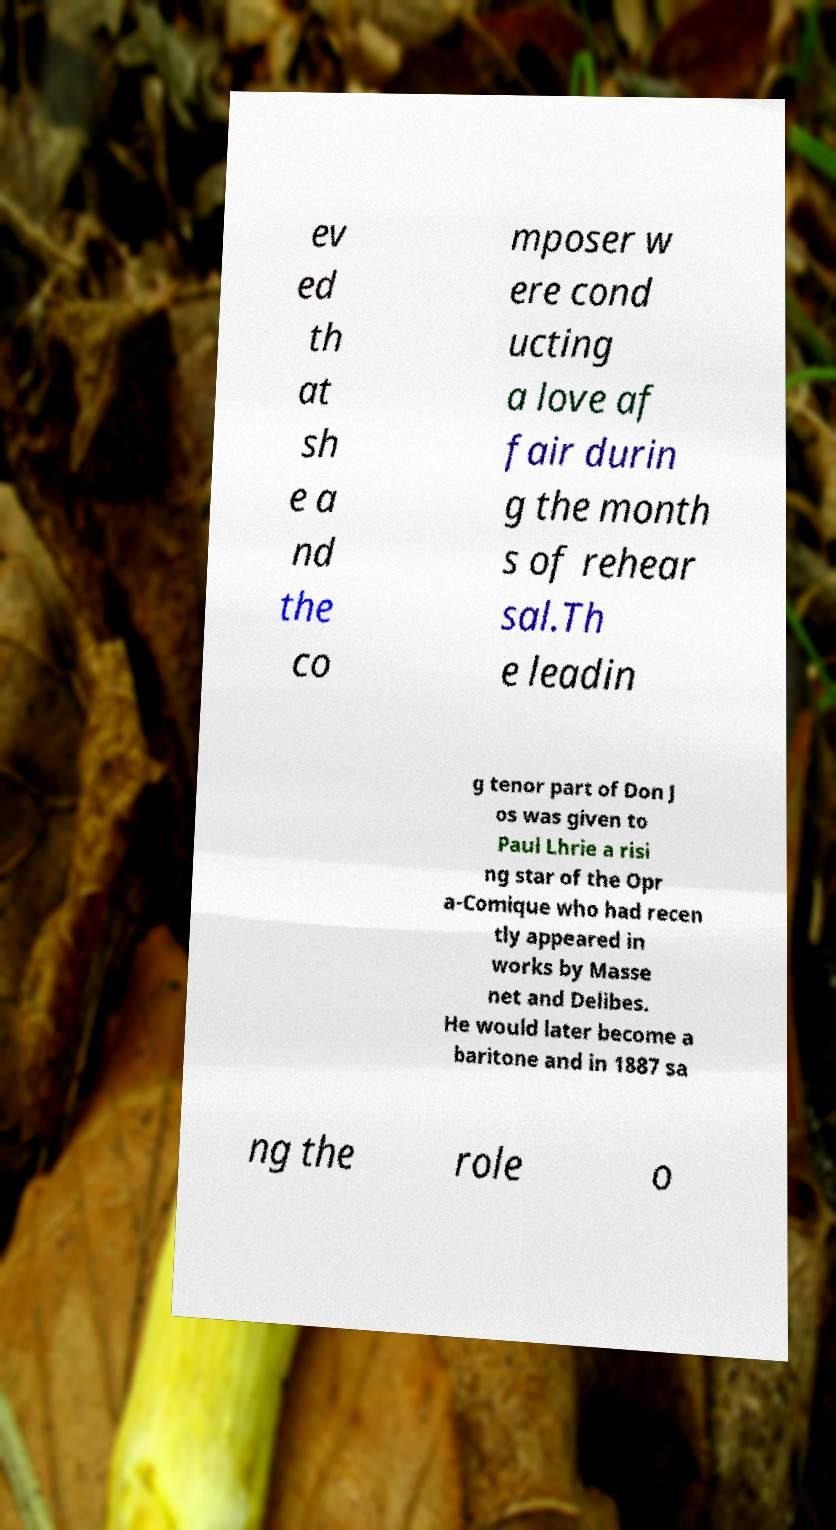Please identify and transcribe the text found in this image. ev ed th at sh e a nd the co mposer w ere cond ucting a love af fair durin g the month s of rehear sal.Th e leadin g tenor part of Don J os was given to Paul Lhrie a risi ng star of the Opr a-Comique who had recen tly appeared in works by Masse net and Delibes. He would later become a baritone and in 1887 sa ng the role o 